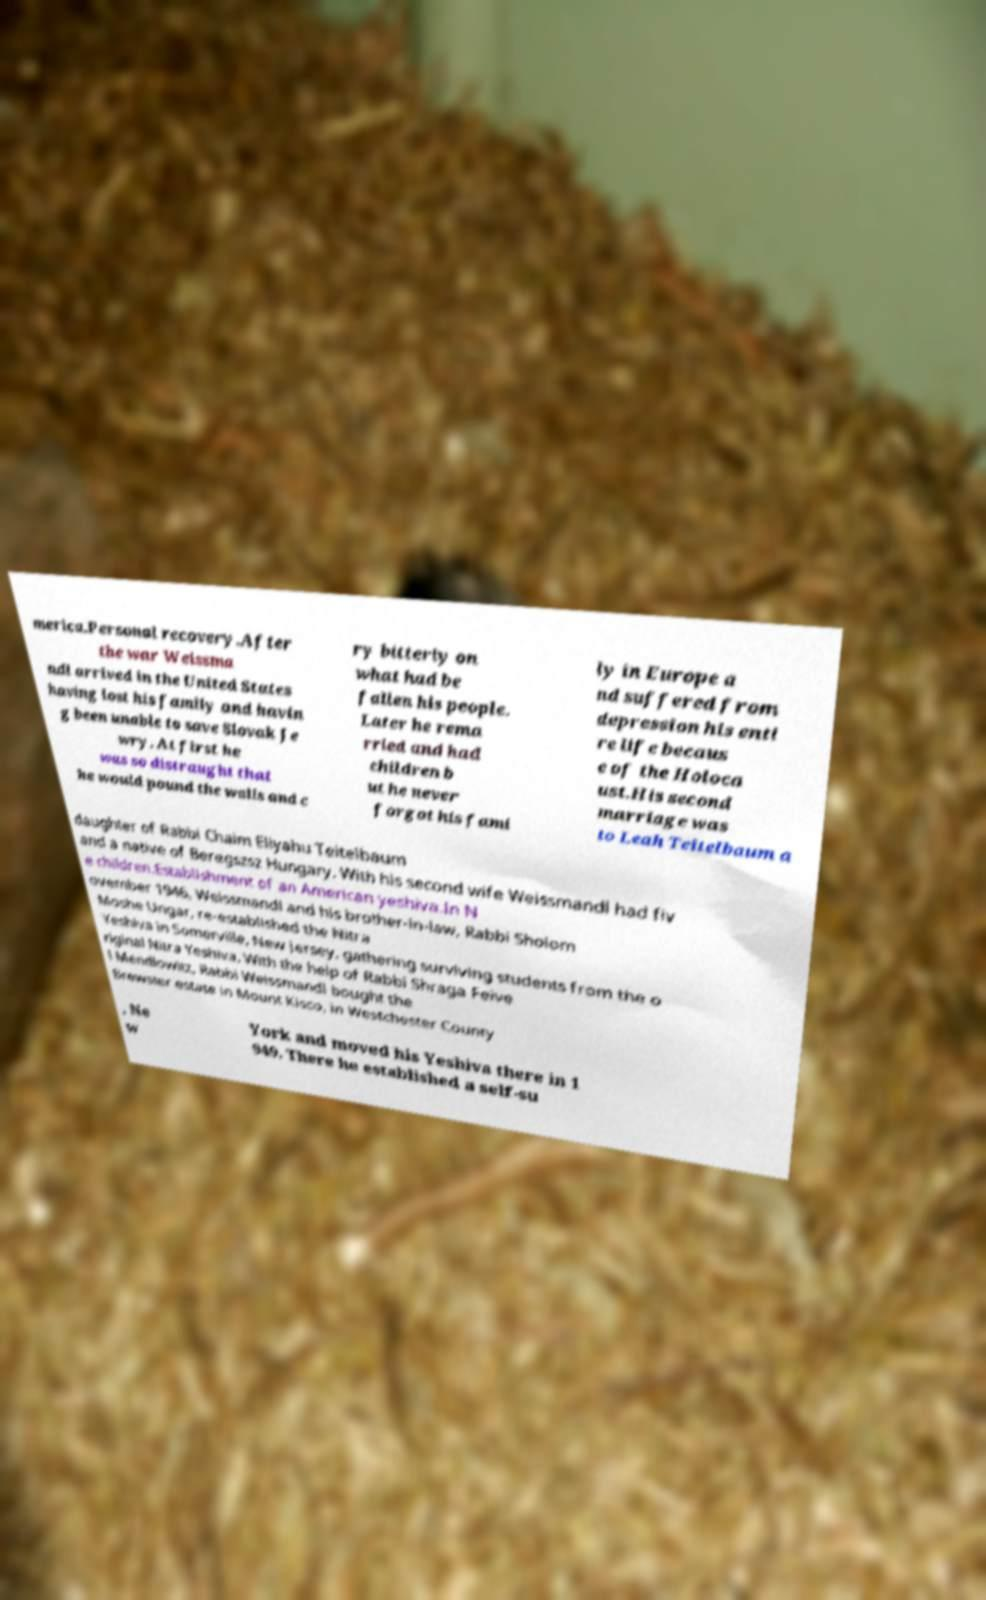I need the written content from this picture converted into text. Can you do that? merica.Personal recovery.After the war Weissma ndl arrived in the United States having lost his family and havin g been unable to save Slovak Je wry. At first he was so distraught that he would pound the walls and c ry bitterly on what had be fallen his people. Later he rema rried and had children b ut he never forgot his fami ly in Europe a nd suffered from depression his enti re life becaus e of the Holoca ust.His second marriage was to Leah Teitelbaum a daughter of Rabbi Chaim Eliyahu Teitelbaum and a native of Beregszsz Hungary. With his second wife Weissmandl had fiv e children.Establishment of an American yeshiva.In N ovember 1946, Weissmandl and his brother-in-law, Rabbi Sholom Moshe Ungar, re-established the Nitra Yeshiva in Somerville, New Jersey, gathering surviving students from the o riginal Nitra Yeshiva. With the help of Rabbi Shraga Feive l Mendlowitz, Rabbi Weissmandl bought the Brewster estate in Mount Kisco, in Westchester County , Ne w York and moved his Yeshiva there in 1 949. There he established a self-su 